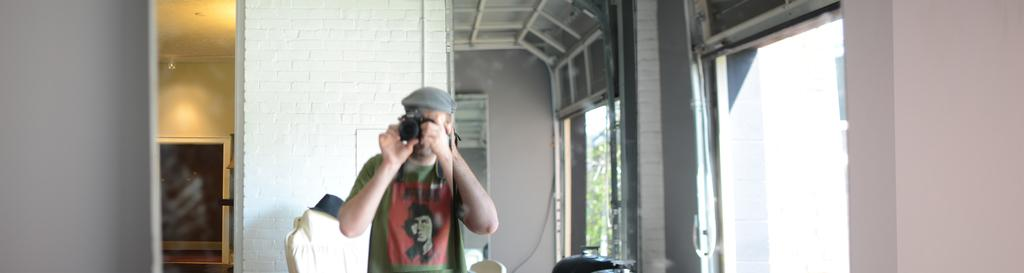What is the person in the image holding? The person in the image is holding a camera. What type of headwear is visible in the image? There is a hat in the image. What piece of furniture can be seen in the image? There is a chair in the image. What type of architectural features are present in the image? There are walls and windows in the image. Can you describe any other objects in the image? There are some other objects in the image, but their specific details are not mentioned in the provided facts. What type of quill is the person using to make a decision in the image? There is no quill or decision-making process depicted in the image; it only shows a person holding a camera. 